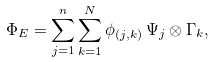Convert formula to latex. <formula><loc_0><loc_0><loc_500><loc_500>\Phi _ { E } = \sum _ { j = 1 } ^ { n } \sum _ { k = 1 } ^ { N } \phi _ { ( j , k ) } \, \Psi _ { j } \otimes \Gamma _ { k } ,</formula> 